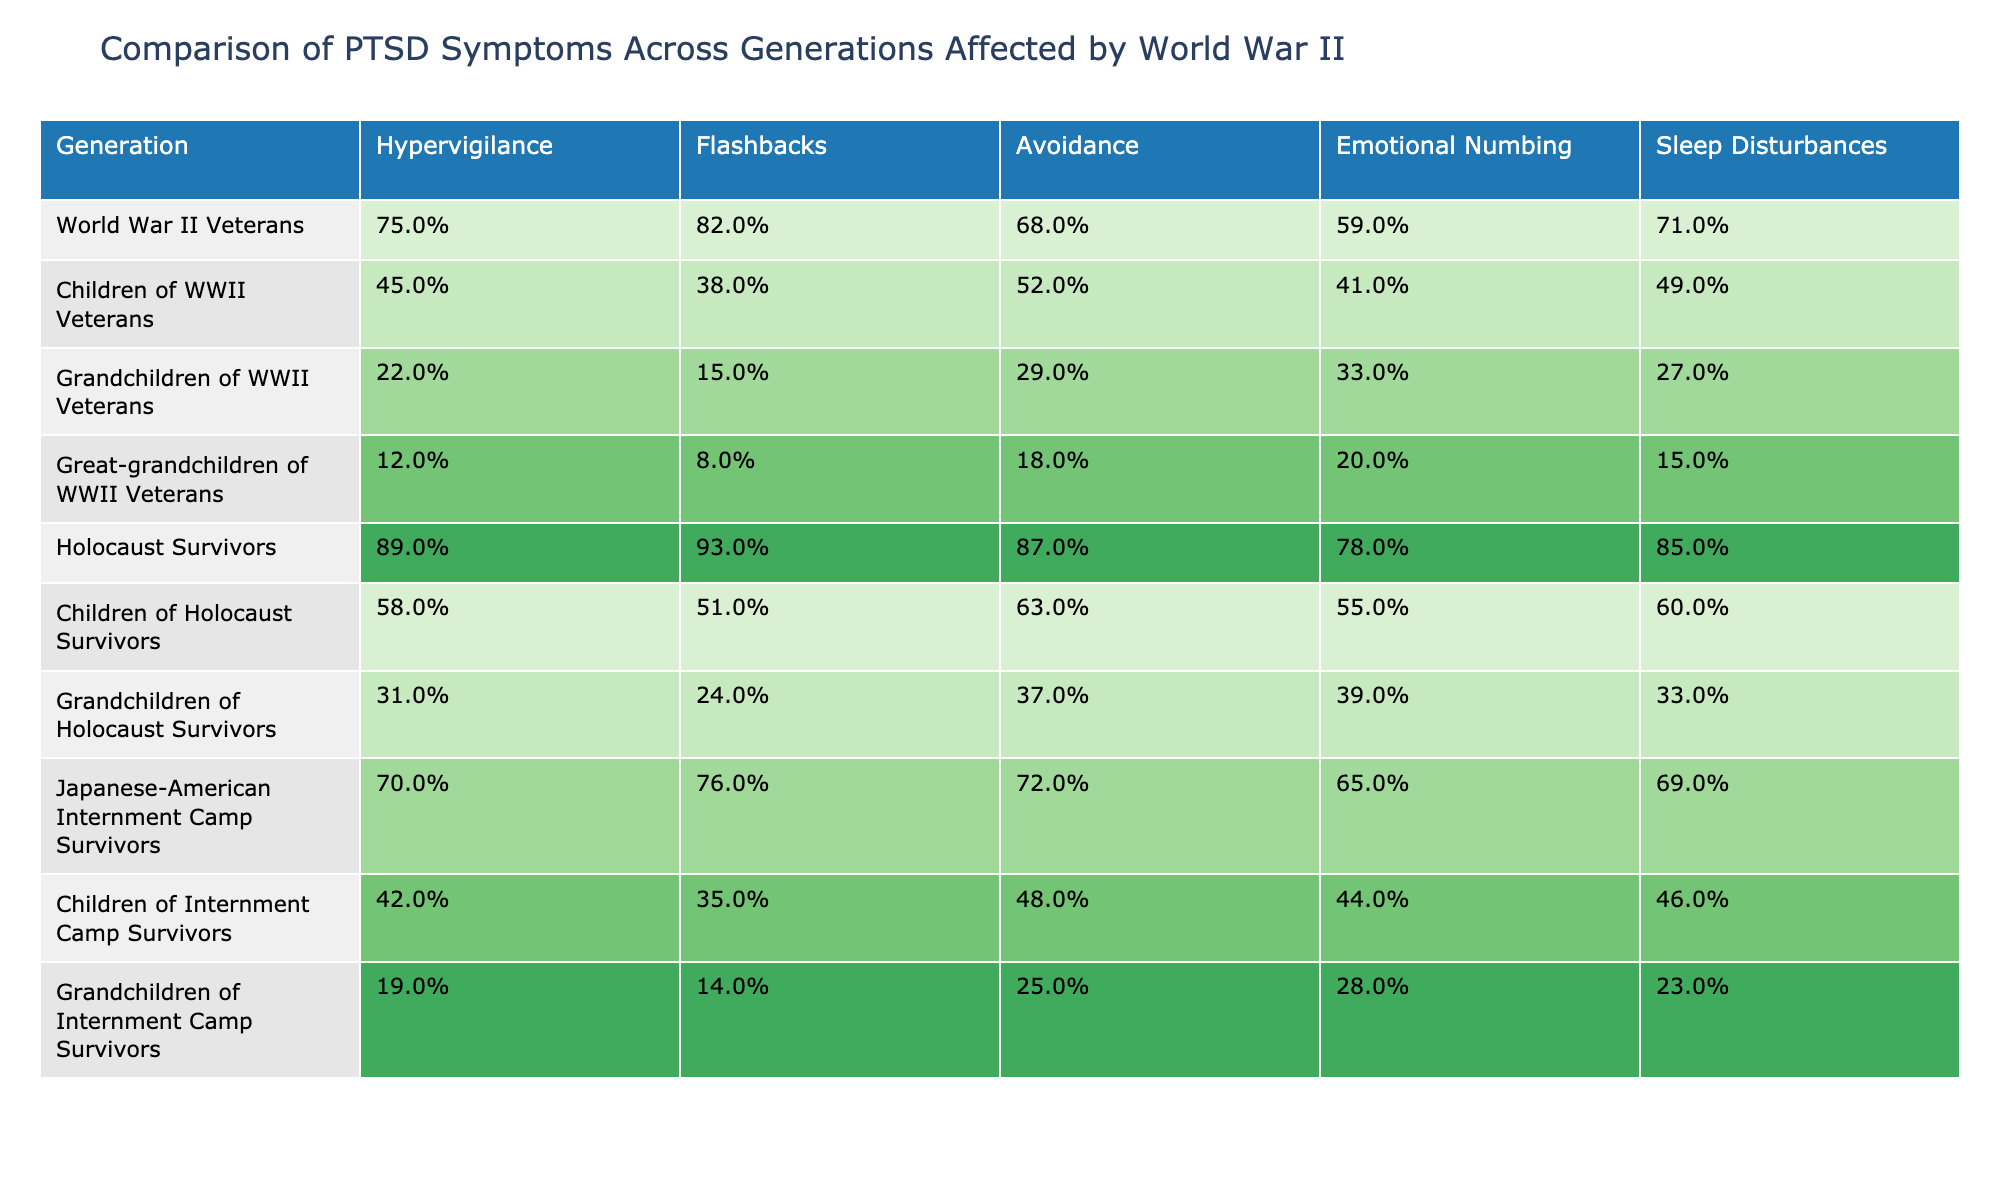What percentage of World War II Veterans experience hypervigilance? The table indicates that 75% of World War II Veterans experience hypervigilance.
Answer: 75% Which generation shows the highest percentage of flashbacks? According to the table, Holocaust Survivors have the highest percentage of flashbacks at 93%.
Answer: 93% What is the percentage difference in emotional numbing between the Children of Holocaust Survivors and the Grandchildren of Holocaust Survivors? The percentage of emotional numbing for Children of Holocaust Survivors is 55%, and for Grandchildren, it is 39%. The difference is 55% - 39% = 16%.
Answer: 16% Do the Great-grandchildren of World War II Veterans have a higher rate of sleep disturbances than the Grandchildren of Internment Camp Survivors? The Great-grandchildren of World War II Veterans have a sleep disturbance rate of 15%, while the Grandchildren of Internment Camp Survivors have a rate of 23%. Thus, the statement is false.
Answer: No What is the average percentage of avoidance symptoms across all generations of Holocaust Survivors and their descendants? The percentages for avoidance are: Holocaust Survivors (87%), Children (63%), Grandchildren (37%). The average is (87% + 63% + 37%) / 3 = 62.33%.
Answer: 62.33% Which group has the lowest reported percentage for hypervigilance, and what is that percentage? The Grandchildren of WWII Veterans have the lowest reported percentage for hypervigilance at 22%.
Answer: 22% How do the PTSD symptoms of Children of WWII Veterans compare collectively to those of World War II Veterans? The Children of WWII Veterans have lower percentages in all symptom categories compared to the World War II Veterans. For instance, they have 45% hypervigilance vs. 75%. This indicates a clear generational drop in symptoms.
Answer: Yes, they are lower What is the overall trend in PTSD symptoms from World War II Veterans to Great-grandchildren? The data shows a decreasing trend in all PTSD symptoms from World War II Veterans (highest percentages) to Great-grandchildren (lowest percentages), reflecting a gradual reduction across generations.
Answer: Decreasing trend What percentage of Japanese-American Internment Camp Survivors experience emotional numbing? The table shows that 65% of Japanese-American Internment Camp Survivors experience emotional numbing.
Answer: 65% Is there a pattern in sleep disturbances between the generations affected by internment camps? Yes, there is a pattern indicating that as generations progress from Internment Camp Survivors (69%) to Children (46%) to Grandchildren (23%), sleep disturbances decrease consistently.
Answer: Yes, it decreases 